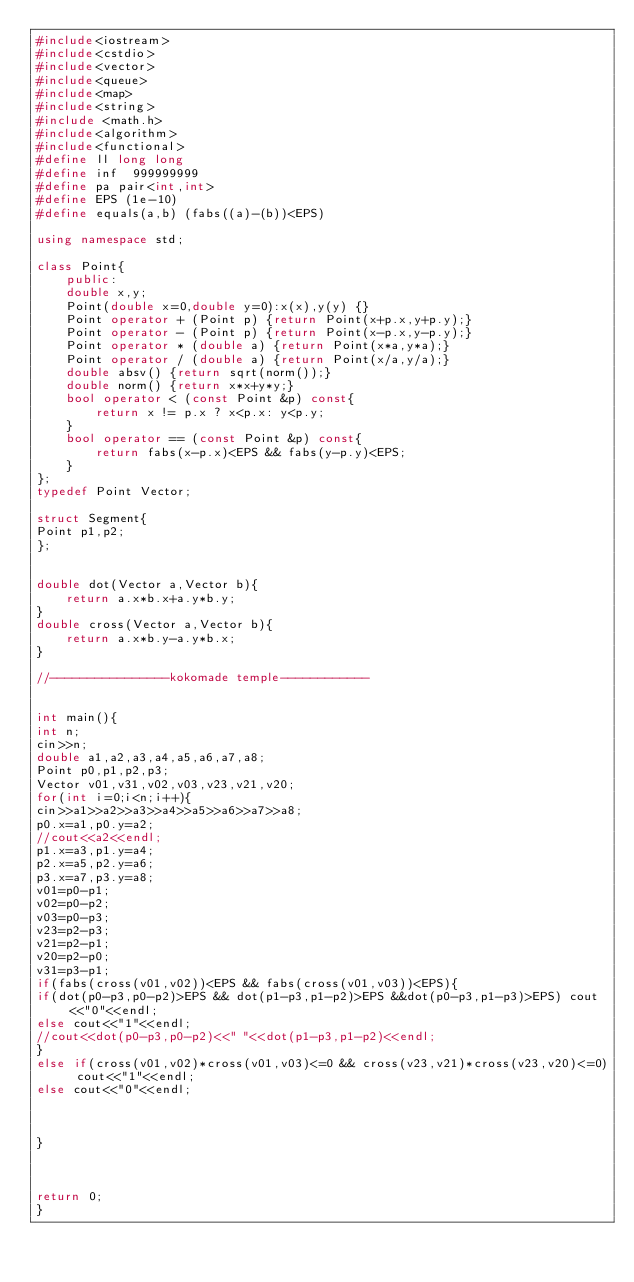Convert code to text. <code><loc_0><loc_0><loc_500><loc_500><_C++_>#include<iostream>
#include<cstdio>
#include<vector>
#include<queue>
#include<map>
#include<string>
#include <math.h>
#include<algorithm>
#include<functional>
#define ll long long
#define inf  999999999
#define pa pair<int,int>
#define EPS (1e-10)
#define equals(a,b) (fabs((a)-(b))<EPS)

using namespace std;

class Point{
	public:
	double x,y;
	Point(double x=0,double y=0):x(x),y(y) {}
	Point operator + (Point p) {return Point(x+p.x,y+p.y);}
	Point operator - (Point p) {return Point(x-p.x,y-p.y);}
	Point operator * (double a) {return Point(x*a,y*a);}
	Point operator / (double a) {return Point(x/a,y/a);}
	double absv() {return sqrt(norm());}
	double norm() {return x*x+y*y;}
	bool operator < (const Point &p) const{
		return x != p.x ? x<p.x: y<p.y;
	}
	bool operator == (const Point &p) const{
		return fabs(x-p.x)<EPS && fabs(y-p.y)<EPS;
	}
};
typedef Point Vector;

struct Segment{
Point p1,p2;
};


double dot(Vector a,Vector b){
	return a.x*b.x+a.y*b.y;
}
double cross(Vector a,Vector b){
	return a.x*b.y-a.y*b.x;
}

//----------------kokomade temple------------


int main(){
int n;
cin>>n;
double a1,a2,a3,a4,a5,a6,a7,a8;
Point p0,p1,p2,p3;
Vector v01,v31,v02,v03,v23,v21,v20;
for(int i=0;i<n;i++){
cin>>a1>>a2>>a3>>a4>>a5>>a6>>a7>>a8;
p0.x=a1,p0.y=a2;
//cout<<a2<<endl;
p1.x=a3,p1.y=a4;
p2.x=a5,p2.y=a6;
p3.x=a7,p3.y=a8;
v01=p0-p1;
v02=p0-p2;
v03=p0-p3;
v23=p2-p3;
v21=p2-p1;
v20=p2-p0;
v31=p3-p1;
if(fabs(cross(v01,v02))<EPS && fabs(cross(v01,v03))<EPS){
if(dot(p0-p3,p0-p2)>EPS && dot(p1-p3,p1-p2)>EPS &&dot(p0-p3,p1-p3)>EPS) cout<<"0"<<endl;
else cout<<"1"<<endl;
//cout<<dot(p0-p3,p0-p2)<<" "<<dot(p1-p3,p1-p2)<<endl;
}
else if(cross(v01,v02)*cross(v01,v03)<=0 && cross(v23,v21)*cross(v23,v20)<=0) cout<<"1"<<endl;
else cout<<"0"<<endl;



}



return 0;
}</code> 